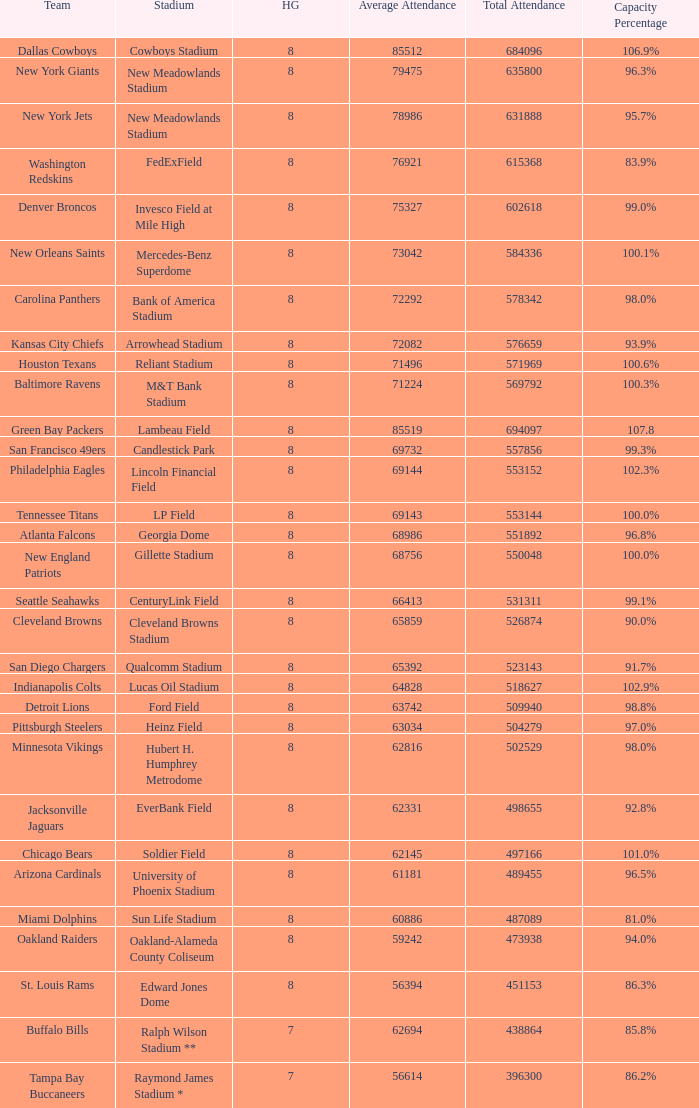What is the name of the team when the stadium is listed as Edward Jones Dome? St. Louis Rams. 